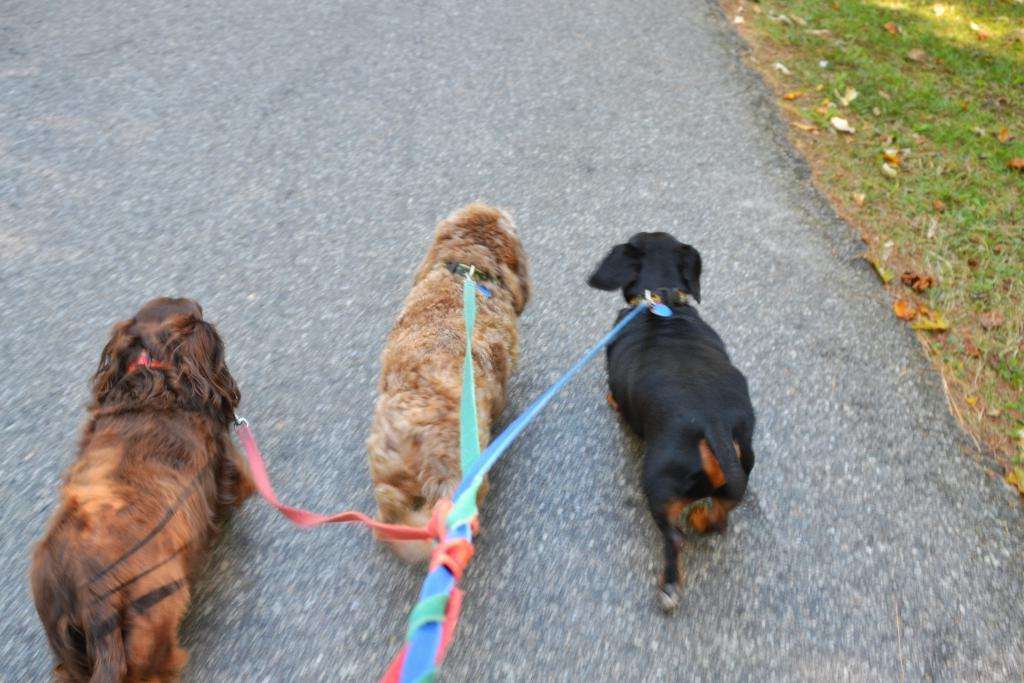How many dogs are present in the image? There are 3 dogs in the image. What is attached to the dogs? The dogs have leashes tied to them. Where are the dogs located? The dogs are on the road. What type of vegetation is on the right side of the image? There is grass on the right side of the image. What is present on the grass? There are leaves on the grass. Can you tell me how many knees are visible in the image? There are no knees visible in the image; it features 3 dogs on the road. What type of fowl can be seen interacting with the dogs in the image? There is no fowl present in the image; only the dogs, leashes, and grass with leaves are visible. 